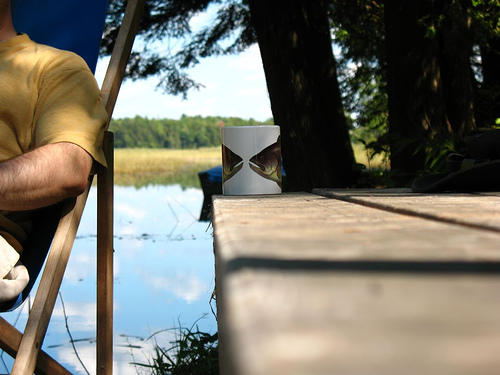<image>
Can you confirm if the mug is next to the tree? Yes. The mug is positioned adjacent to the tree, located nearby in the same general area. 